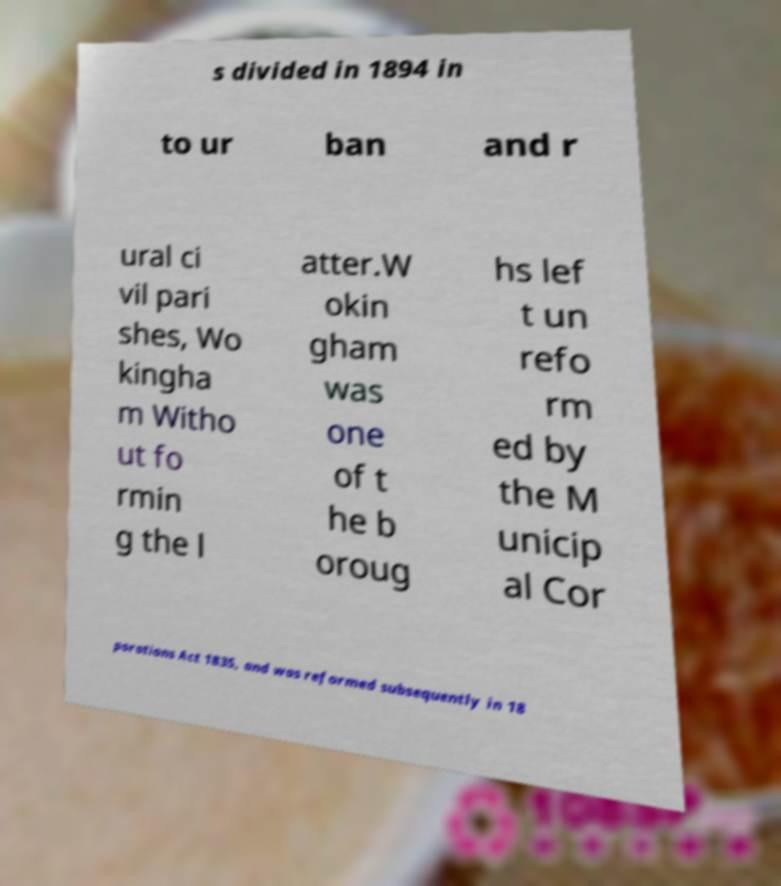What messages or text are displayed in this image? I need them in a readable, typed format. s divided in 1894 in to ur ban and r ural ci vil pari shes, Wo kingha m Witho ut fo rmin g the l atter.W okin gham was one of t he b oroug hs lef t un refo rm ed by the M unicip al Cor porations Act 1835, and was reformed subsequently in 18 